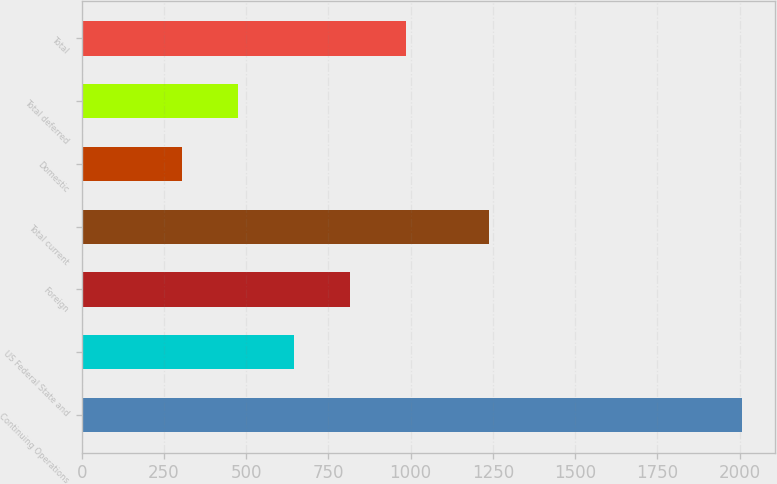<chart> <loc_0><loc_0><loc_500><loc_500><bar_chart><fcel>Continuing Operations<fcel>US Federal State and<fcel>Foreign<fcel>Total current<fcel>Domestic<fcel>Total deferred<fcel>Total<nl><fcel>2007<fcel>644.6<fcel>814.9<fcel>1239<fcel>304<fcel>474.3<fcel>985.2<nl></chart> 